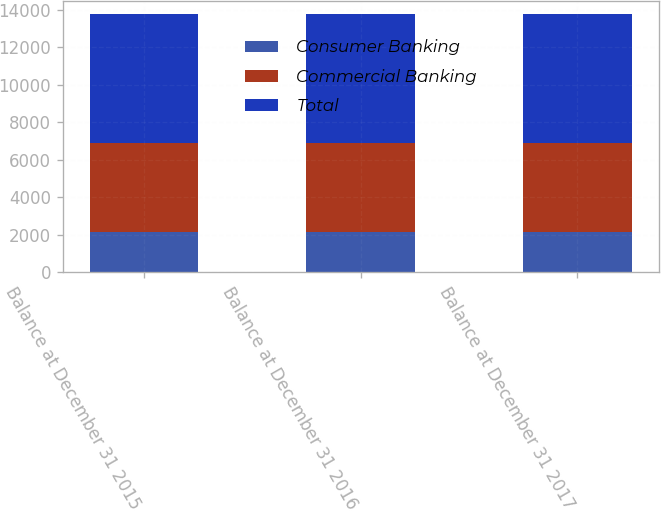Convert chart to OTSL. <chart><loc_0><loc_0><loc_500><loc_500><stacked_bar_chart><ecel><fcel>Balance at December 31 2015<fcel>Balance at December 31 2016<fcel>Balance at December 31 2017<nl><fcel>Consumer Banking<fcel>2136<fcel>2136<fcel>2136<nl><fcel>Commercial Banking<fcel>4740<fcel>4740<fcel>4751<nl><fcel>Total<fcel>6876<fcel>6876<fcel>6887<nl></chart> 